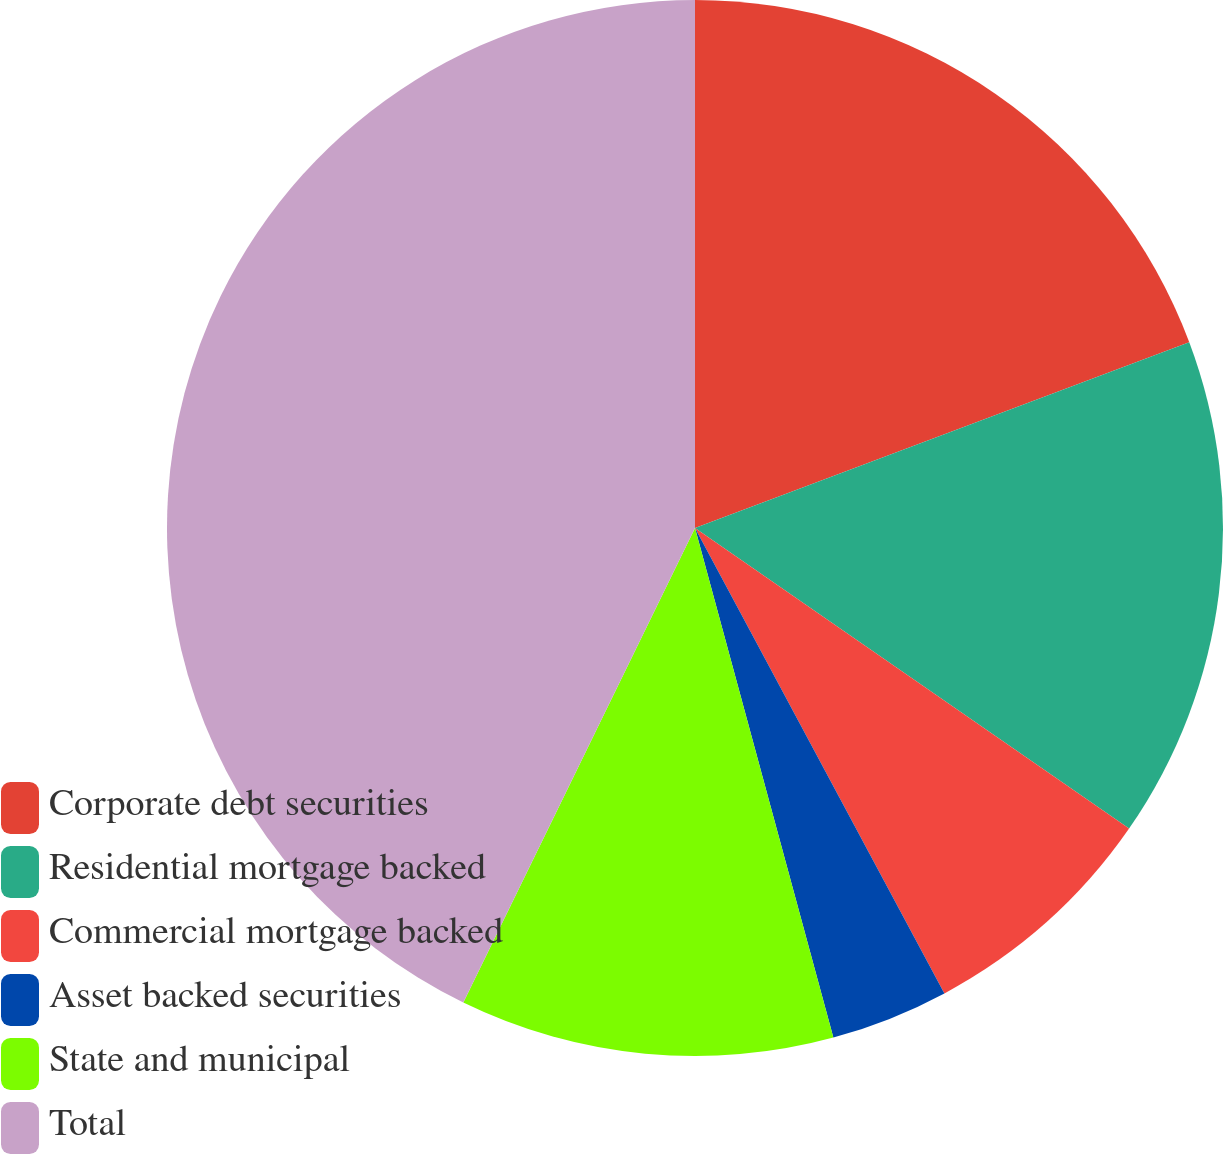<chart> <loc_0><loc_0><loc_500><loc_500><pie_chart><fcel>Corporate debt securities<fcel>Residential mortgage backed<fcel>Commercial mortgage backed<fcel>Asset backed securities<fcel>State and municipal<fcel>Total<nl><fcel>19.28%<fcel>15.36%<fcel>7.53%<fcel>3.61%<fcel>11.45%<fcel>42.77%<nl></chart> 